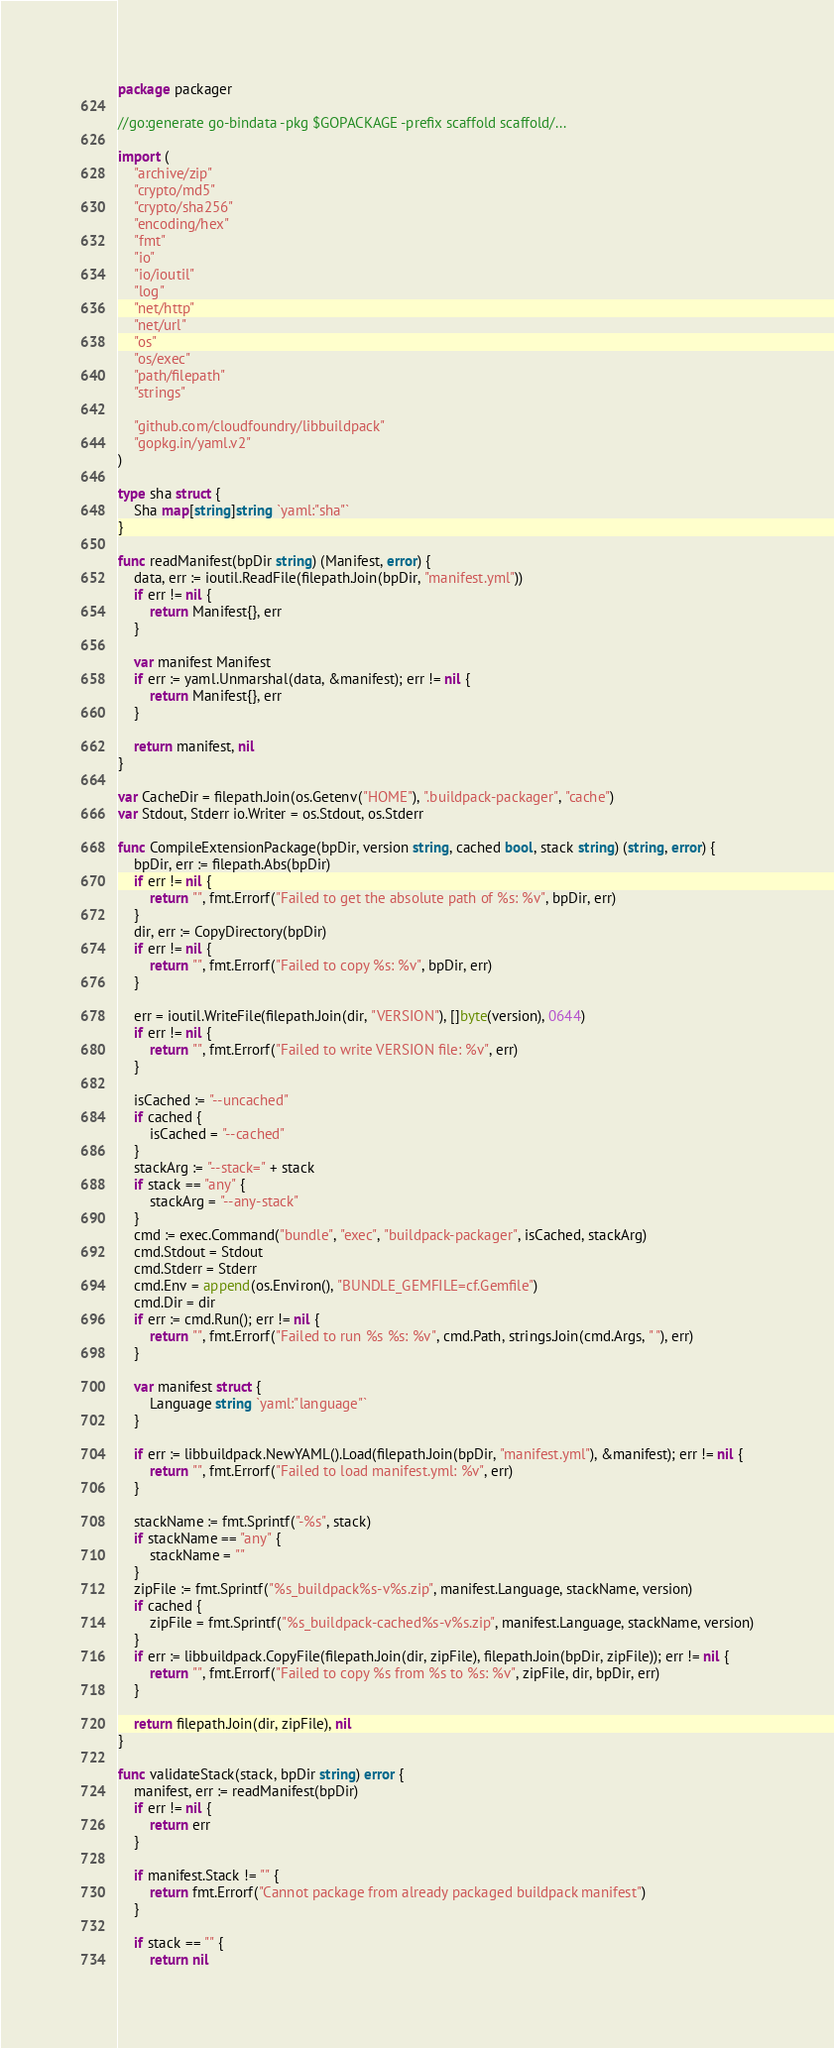Convert code to text. <code><loc_0><loc_0><loc_500><loc_500><_Go_>package packager

//go:generate go-bindata -pkg $GOPACKAGE -prefix scaffold scaffold/...

import (
	"archive/zip"
	"crypto/md5"
	"crypto/sha256"
	"encoding/hex"
	"fmt"
	"io"
	"io/ioutil"
	"log"
	"net/http"
	"net/url"
	"os"
	"os/exec"
	"path/filepath"
	"strings"

	"github.com/cloudfoundry/libbuildpack"
	"gopkg.in/yaml.v2"
)

type sha struct {
	Sha map[string]string `yaml:"sha"`
}

func readManifest(bpDir string) (Manifest, error) {
	data, err := ioutil.ReadFile(filepath.Join(bpDir, "manifest.yml"))
	if err != nil {
		return Manifest{}, err
	}

	var manifest Manifest
	if err := yaml.Unmarshal(data, &manifest); err != nil {
		return Manifest{}, err
	}

	return manifest, nil
}

var CacheDir = filepath.Join(os.Getenv("HOME"), ".buildpack-packager", "cache")
var Stdout, Stderr io.Writer = os.Stdout, os.Stderr

func CompileExtensionPackage(bpDir, version string, cached bool, stack string) (string, error) {
	bpDir, err := filepath.Abs(bpDir)
	if err != nil {
		return "", fmt.Errorf("Failed to get the absolute path of %s: %v", bpDir, err)
	}
	dir, err := CopyDirectory(bpDir)
	if err != nil {
		return "", fmt.Errorf("Failed to copy %s: %v", bpDir, err)
	}

	err = ioutil.WriteFile(filepath.Join(dir, "VERSION"), []byte(version), 0644)
	if err != nil {
		return "", fmt.Errorf("Failed to write VERSION file: %v", err)
	}

	isCached := "--uncached"
	if cached {
		isCached = "--cached"
	}
	stackArg := "--stack=" + stack
	if stack == "any" {
		stackArg = "--any-stack"
	}
	cmd := exec.Command("bundle", "exec", "buildpack-packager", isCached, stackArg)
	cmd.Stdout = Stdout
	cmd.Stderr = Stderr
	cmd.Env = append(os.Environ(), "BUNDLE_GEMFILE=cf.Gemfile")
	cmd.Dir = dir
	if err := cmd.Run(); err != nil {
		return "", fmt.Errorf("Failed to run %s %s: %v", cmd.Path, strings.Join(cmd.Args, " "), err)
	}

	var manifest struct {
		Language string `yaml:"language"`
	}

	if err := libbuildpack.NewYAML().Load(filepath.Join(bpDir, "manifest.yml"), &manifest); err != nil {
		return "", fmt.Errorf("Failed to load manifest.yml: %v", err)
	}

	stackName := fmt.Sprintf("-%s", stack)
	if stackName == "any" {
		stackName = ""
	}
	zipFile := fmt.Sprintf("%s_buildpack%s-v%s.zip", manifest.Language, stackName, version)
	if cached {
		zipFile = fmt.Sprintf("%s_buildpack-cached%s-v%s.zip", manifest.Language, stackName, version)
	}
	if err := libbuildpack.CopyFile(filepath.Join(dir, zipFile), filepath.Join(bpDir, zipFile)); err != nil {
		return "", fmt.Errorf("Failed to copy %s from %s to %s: %v", zipFile, dir, bpDir, err)
	}

	return filepath.Join(dir, zipFile), nil
}

func validateStack(stack, bpDir string) error {
	manifest, err := readManifest(bpDir)
	if err != nil {
		return err
	}

	if manifest.Stack != "" {
		return fmt.Errorf("Cannot package from already packaged buildpack manifest")
	}

	if stack == "" {
		return nil</code> 